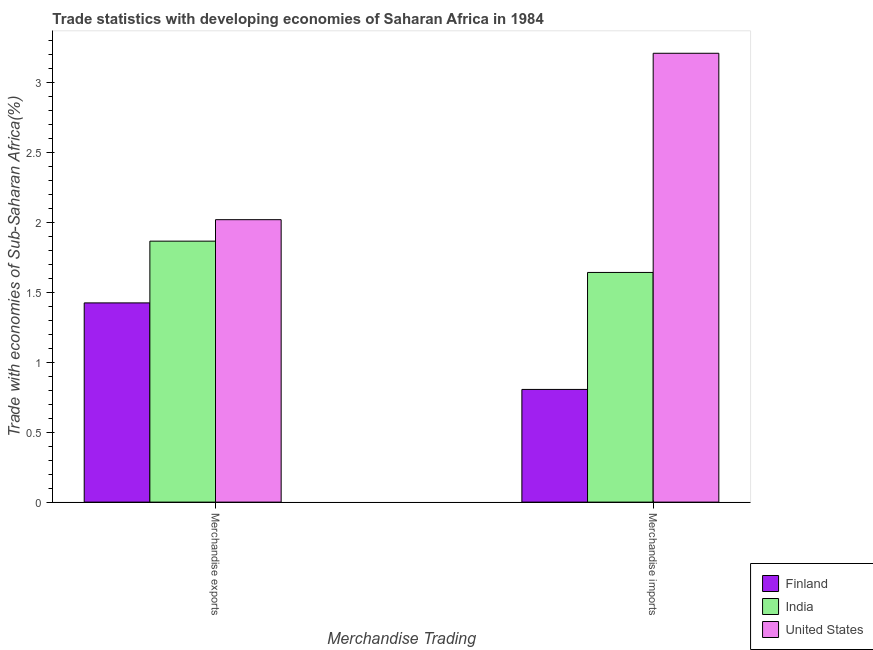How many different coloured bars are there?
Provide a short and direct response. 3. How many groups of bars are there?
Offer a very short reply. 2. How many bars are there on the 2nd tick from the left?
Give a very brief answer. 3. How many bars are there on the 1st tick from the right?
Ensure brevity in your answer.  3. What is the label of the 2nd group of bars from the left?
Provide a short and direct response. Merchandise imports. What is the merchandise exports in India?
Provide a succinct answer. 1.87. Across all countries, what is the maximum merchandise exports?
Provide a short and direct response. 2.02. Across all countries, what is the minimum merchandise exports?
Provide a succinct answer. 1.42. In which country was the merchandise exports maximum?
Offer a terse response. United States. In which country was the merchandise exports minimum?
Your answer should be compact. Finland. What is the total merchandise imports in the graph?
Keep it short and to the point. 5.66. What is the difference between the merchandise exports in Finland and that in India?
Give a very brief answer. -0.44. What is the difference between the merchandise imports in Finland and the merchandise exports in India?
Your answer should be compact. -1.06. What is the average merchandise imports per country?
Make the answer very short. 1.89. What is the difference between the merchandise exports and merchandise imports in India?
Keep it short and to the point. 0.22. In how many countries, is the merchandise exports greater than 2.5 %?
Offer a very short reply. 0. What is the ratio of the merchandise exports in India to that in Finland?
Offer a very short reply. 1.31. Is the merchandise imports in United States less than that in India?
Make the answer very short. No. What does the 1st bar from the right in Merchandise imports represents?
Your response must be concise. United States. Are all the bars in the graph horizontal?
Give a very brief answer. No. Are the values on the major ticks of Y-axis written in scientific E-notation?
Offer a terse response. No. Does the graph contain grids?
Make the answer very short. No. How are the legend labels stacked?
Offer a very short reply. Vertical. What is the title of the graph?
Give a very brief answer. Trade statistics with developing economies of Saharan Africa in 1984. Does "Antigua and Barbuda" appear as one of the legend labels in the graph?
Make the answer very short. No. What is the label or title of the X-axis?
Provide a short and direct response. Merchandise Trading. What is the label or title of the Y-axis?
Your answer should be very brief. Trade with economies of Sub-Saharan Africa(%). What is the Trade with economies of Sub-Saharan Africa(%) of Finland in Merchandise exports?
Offer a terse response. 1.42. What is the Trade with economies of Sub-Saharan Africa(%) of India in Merchandise exports?
Offer a very short reply. 1.87. What is the Trade with economies of Sub-Saharan Africa(%) in United States in Merchandise exports?
Offer a very short reply. 2.02. What is the Trade with economies of Sub-Saharan Africa(%) of Finland in Merchandise imports?
Ensure brevity in your answer.  0.81. What is the Trade with economies of Sub-Saharan Africa(%) of India in Merchandise imports?
Offer a very short reply. 1.64. What is the Trade with economies of Sub-Saharan Africa(%) in United States in Merchandise imports?
Provide a short and direct response. 3.21. Across all Merchandise Trading, what is the maximum Trade with economies of Sub-Saharan Africa(%) of Finland?
Keep it short and to the point. 1.42. Across all Merchandise Trading, what is the maximum Trade with economies of Sub-Saharan Africa(%) in India?
Ensure brevity in your answer.  1.87. Across all Merchandise Trading, what is the maximum Trade with economies of Sub-Saharan Africa(%) of United States?
Ensure brevity in your answer.  3.21. Across all Merchandise Trading, what is the minimum Trade with economies of Sub-Saharan Africa(%) in Finland?
Make the answer very short. 0.81. Across all Merchandise Trading, what is the minimum Trade with economies of Sub-Saharan Africa(%) in India?
Provide a short and direct response. 1.64. Across all Merchandise Trading, what is the minimum Trade with economies of Sub-Saharan Africa(%) in United States?
Give a very brief answer. 2.02. What is the total Trade with economies of Sub-Saharan Africa(%) in Finland in the graph?
Your answer should be very brief. 2.23. What is the total Trade with economies of Sub-Saharan Africa(%) in India in the graph?
Ensure brevity in your answer.  3.51. What is the total Trade with economies of Sub-Saharan Africa(%) in United States in the graph?
Give a very brief answer. 5.23. What is the difference between the Trade with economies of Sub-Saharan Africa(%) of Finland in Merchandise exports and that in Merchandise imports?
Offer a terse response. 0.62. What is the difference between the Trade with economies of Sub-Saharan Africa(%) of India in Merchandise exports and that in Merchandise imports?
Give a very brief answer. 0.22. What is the difference between the Trade with economies of Sub-Saharan Africa(%) in United States in Merchandise exports and that in Merchandise imports?
Your response must be concise. -1.19. What is the difference between the Trade with economies of Sub-Saharan Africa(%) in Finland in Merchandise exports and the Trade with economies of Sub-Saharan Africa(%) in India in Merchandise imports?
Make the answer very short. -0.22. What is the difference between the Trade with economies of Sub-Saharan Africa(%) of Finland in Merchandise exports and the Trade with economies of Sub-Saharan Africa(%) of United States in Merchandise imports?
Provide a succinct answer. -1.78. What is the difference between the Trade with economies of Sub-Saharan Africa(%) in India in Merchandise exports and the Trade with economies of Sub-Saharan Africa(%) in United States in Merchandise imports?
Give a very brief answer. -1.34. What is the average Trade with economies of Sub-Saharan Africa(%) in Finland per Merchandise Trading?
Provide a succinct answer. 1.11. What is the average Trade with economies of Sub-Saharan Africa(%) in India per Merchandise Trading?
Ensure brevity in your answer.  1.75. What is the average Trade with economies of Sub-Saharan Africa(%) of United States per Merchandise Trading?
Offer a very short reply. 2.61. What is the difference between the Trade with economies of Sub-Saharan Africa(%) in Finland and Trade with economies of Sub-Saharan Africa(%) in India in Merchandise exports?
Give a very brief answer. -0.44. What is the difference between the Trade with economies of Sub-Saharan Africa(%) in Finland and Trade with economies of Sub-Saharan Africa(%) in United States in Merchandise exports?
Provide a succinct answer. -0.59. What is the difference between the Trade with economies of Sub-Saharan Africa(%) in India and Trade with economies of Sub-Saharan Africa(%) in United States in Merchandise exports?
Offer a very short reply. -0.15. What is the difference between the Trade with economies of Sub-Saharan Africa(%) in Finland and Trade with economies of Sub-Saharan Africa(%) in India in Merchandise imports?
Keep it short and to the point. -0.84. What is the difference between the Trade with economies of Sub-Saharan Africa(%) of Finland and Trade with economies of Sub-Saharan Africa(%) of United States in Merchandise imports?
Make the answer very short. -2.4. What is the difference between the Trade with economies of Sub-Saharan Africa(%) of India and Trade with economies of Sub-Saharan Africa(%) of United States in Merchandise imports?
Ensure brevity in your answer.  -1.57. What is the ratio of the Trade with economies of Sub-Saharan Africa(%) in Finland in Merchandise exports to that in Merchandise imports?
Offer a very short reply. 1.77. What is the ratio of the Trade with economies of Sub-Saharan Africa(%) in India in Merchandise exports to that in Merchandise imports?
Provide a succinct answer. 1.14. What is the ratio of the Trade with economies of Sub-Saharan Africa(%) of United States in Merchandise exports to that in Merchandise imports?
Your answer should be compact. 0.63. What is the difference between the highest and the second highest Trade with economies of Sub-Saharan Africa(%) in Finland?
Keep it short and to the point. 0.62. What is the difference between the highest and the second highest Trade with economies of Sub-Saharan Africa(%) of India?
Keep it short and to the point. 0.22. What is the difference between the highest and the second highest Trade with economies of Sub-Saharan Africa(%) in United States?
Offer a very short reply. 1.19. What is the difference between the highest and the lowest Trade with economies of Sub-Saharan Africa(%) of Finland?
Give a very brief answer. 0.62. What is the difference between the highest and the lowest Trade with economies of Sub-Saharan Africa(%) in India?
Make the answer very short. 0.22. What is the difference between the highest and the lowest Trade with economies of Sub-Saharan Africa(%) in United States?
Offer a terse response. 1.19. 